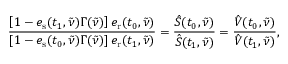<formula> <loc_0><loc_0><loc_500><loc_500>\frac { \left [ 1 - e _ { s } ( t _ { 1 } , \tilde { \nu } ) \Gamma ( \tilde { \nu } ) \right ] e _ { r } ( t _ { 0 } , \tilde { \nu } ) } { \left [ 1 - e _ { s } ( t _ { 0 } , \tilde { \nu } ) \Gamma ( \tilde { \nu } ) \right ] e _ { r } ( t _ { 1 } , \tilde { \nu } ) } = \frac { \hat { S } ( t _ { 0 } , \tilde { \nu } ) } { \hat { S } ( t _ { 1 } , \tilde { \nu } ) } = \frac { \hat { V } ( t _ { 0 } , \tilde { \nu } ) } { \hat { V } ( t _ { 1 } , \tilde { \nu } ) } ,</formula> 